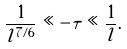Convert formula to latex. <formula><loc_0><loc_0><loc_500><loc_500>\frac { 1 } { l ^ { 7 / 6 } } \ll - \tau \ll \frac { 1 } { l } .</formula> 